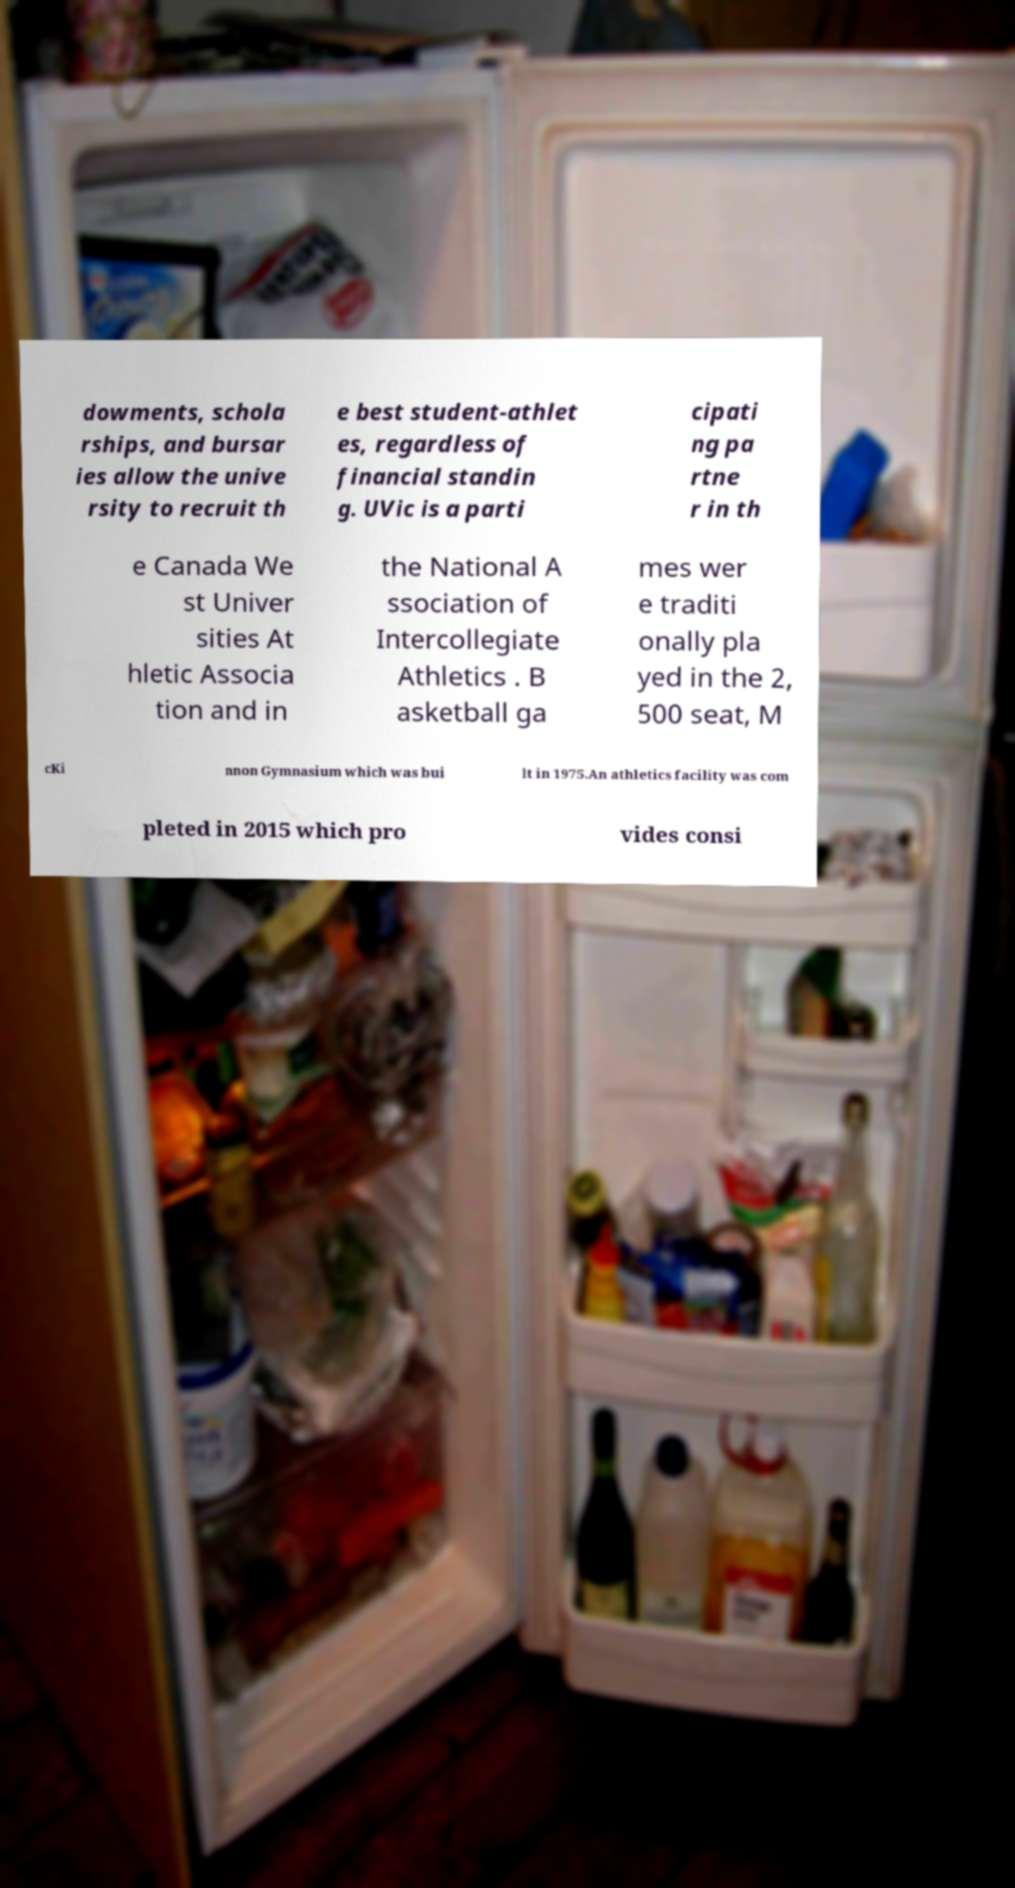What messages or text are displayed in this image? I need them in a readable, typed format. dowments, schola rships, and bursar ies allow the unive rsity to recruit th e best student-athlet es, regardless of financial standin g. UVic is a parti cipati ng pa rtne r in th e Canada We st Univer sities At hletic Associa tion and in the National A ssociation of Intercollegiate Athletics . B asketball ga mes wer e traditi onally pla yed in the 2, 500 seat, M cKi nnon Gymnasium which was bui lt in 1975.An athletics facility was com pleted in 2015 which pro vides consi 